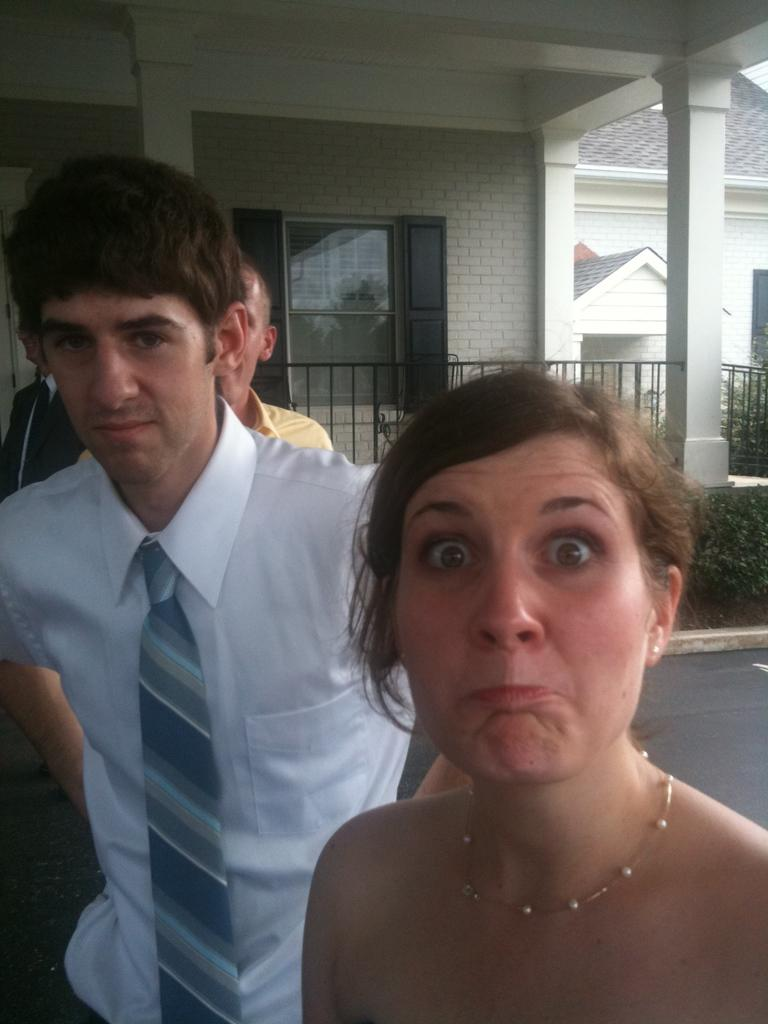Where is the woman located in the image? The woman is in the foreground on the right side of the image. What is happening on the left side of the image? There are men standing on the left side of the image. What can be seen in the background of the image? There is a house, railing, and plants in the background of the image. What type of rock is the goose sitting on in the image? There is no goose or rock present in the image. What is the aftermath of the event in the image? There is no event or aftermath mentioned in the image; it simply shows a woman, men, and a background scene. 